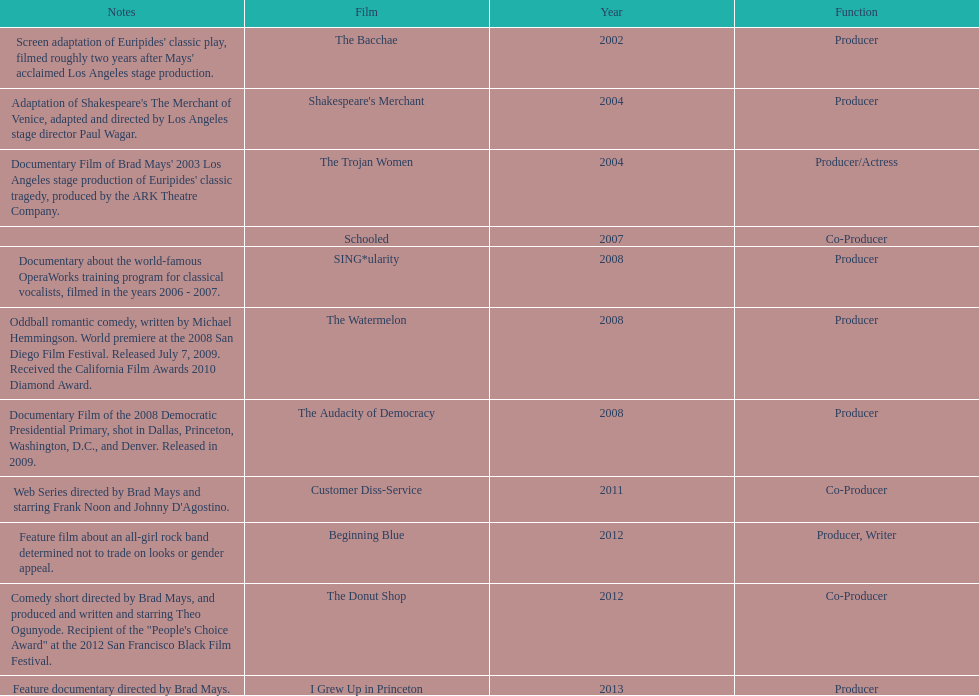Who was the first producer that made the film sing*ularity? Lorenda Starfelt. 